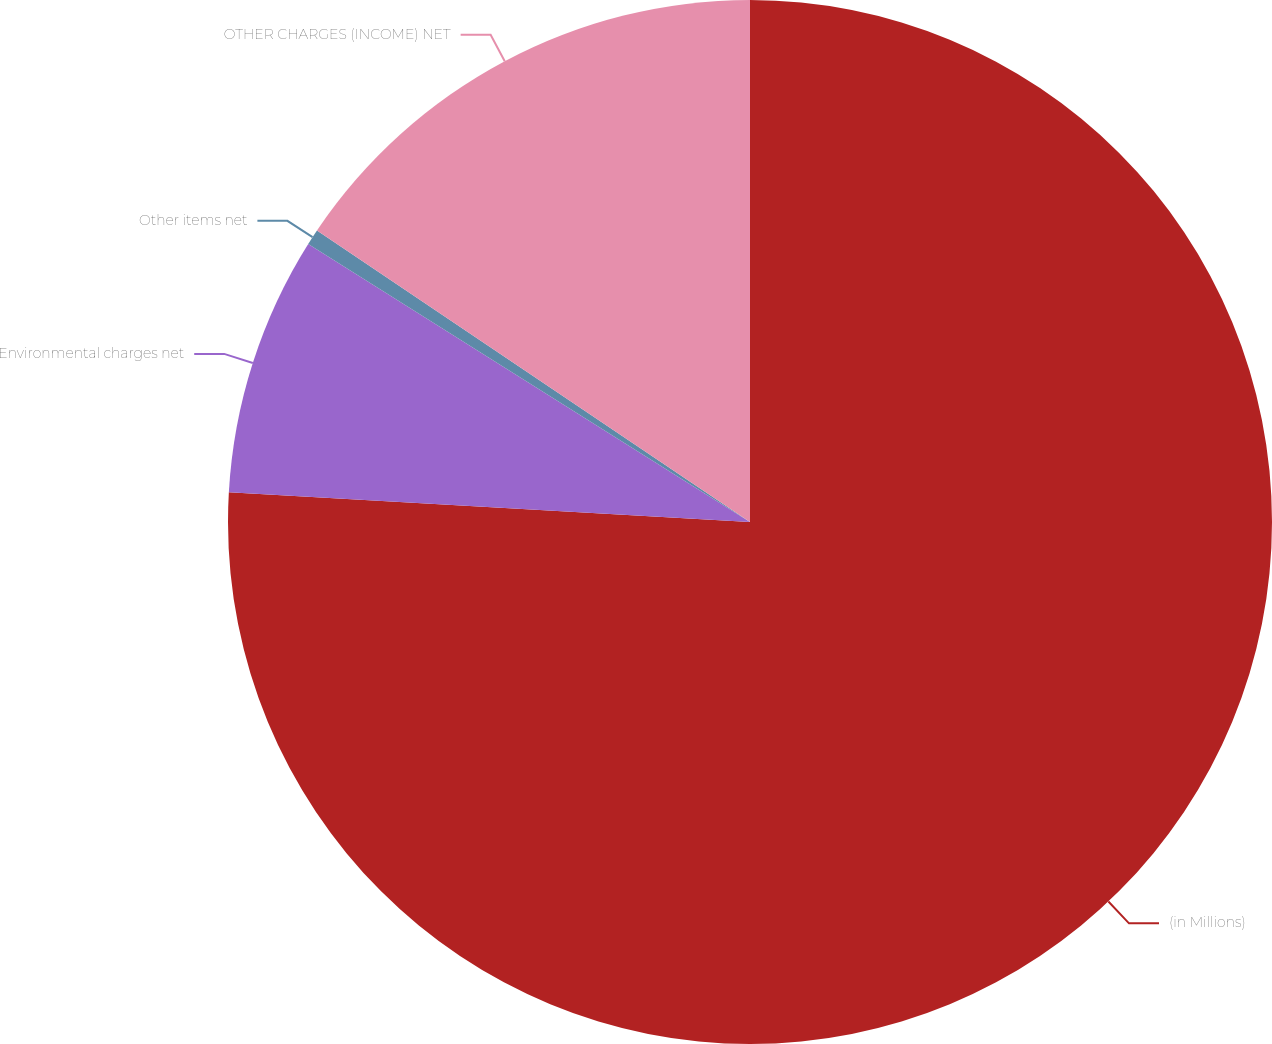<chart> <loc_0><loc_0><loc_500><loc_500><pie_chart><fcel>(in Millions)<fcel>Environmental charges net<fcel>Other items net<fcel>OTHER CHARGES (INCOME) NET<nl><fcel>75.91%<fcel>8.03%<fcel>0.49%<fcel>15.57%<nl></chart> 